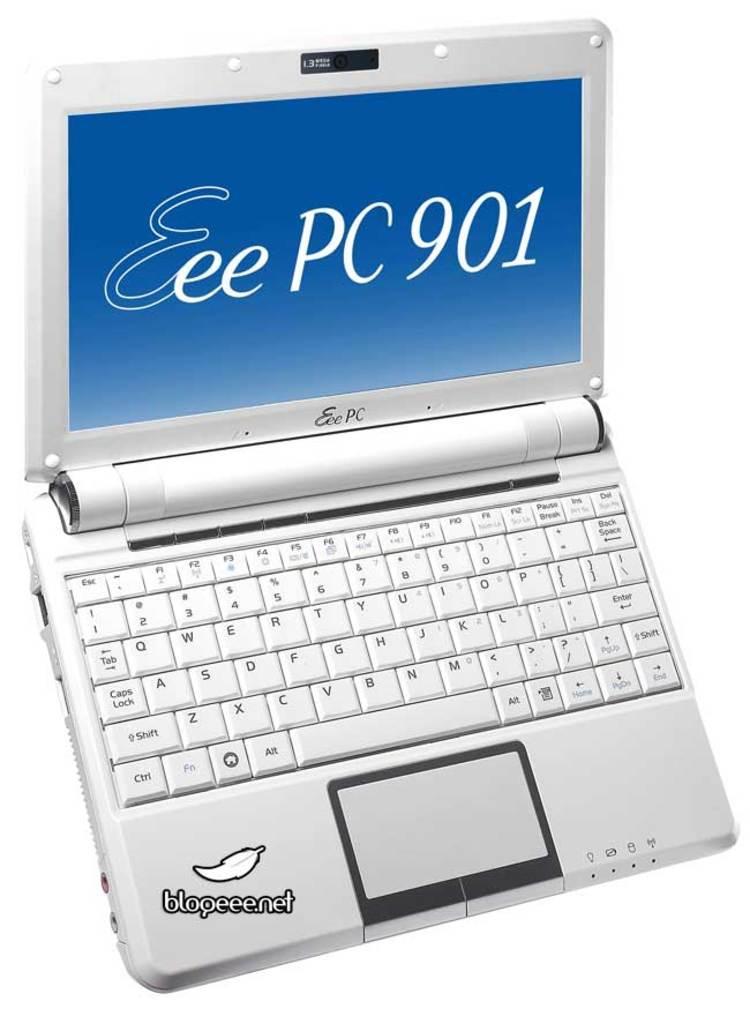<image>
Summarize the visual content of the image. A small laptop with the words Eee PC 901 on the screen 